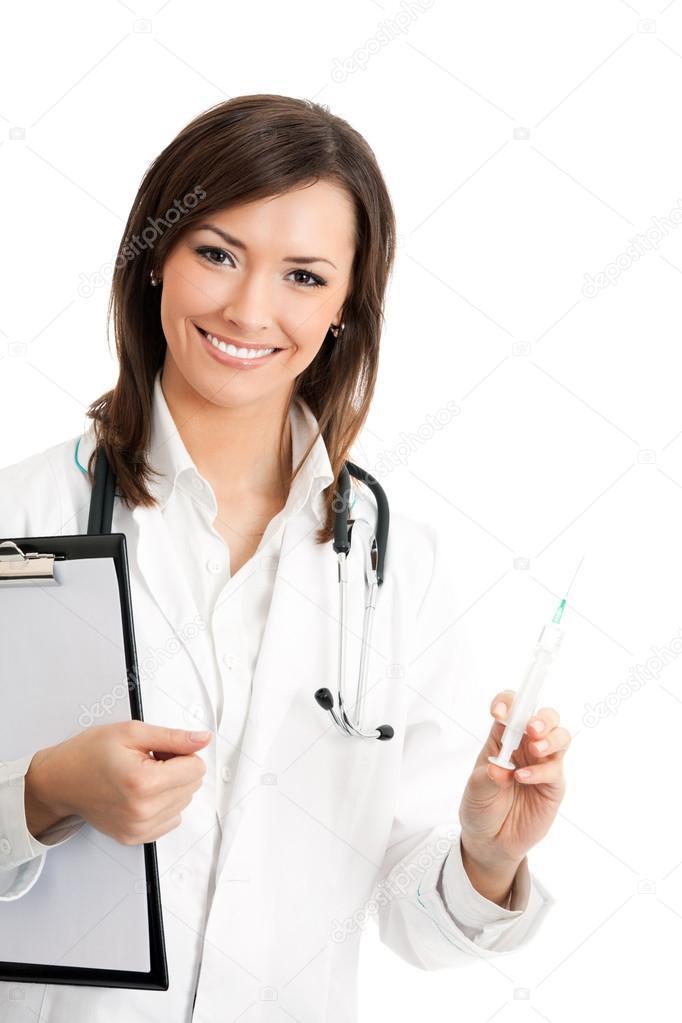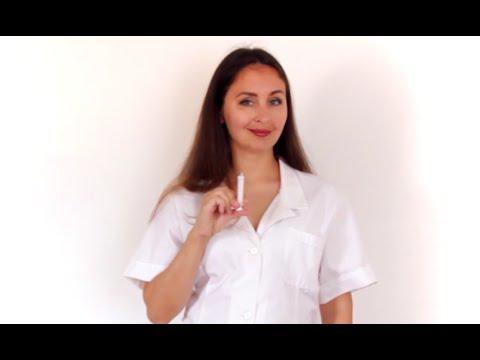The first image is the image on the left, the second image is the image on the right. Evaluate the accuracy of this statement regarding the images: "The liquid in at least one of the syringes is orange.". Is it true? Answer yes or no. No. The first image is the image on the left, the second image is the image on the right. Analyze the images presented: Is the assertion "There are two women holding a needle with colored liquid in it." valid? Answer yes or no. No. 